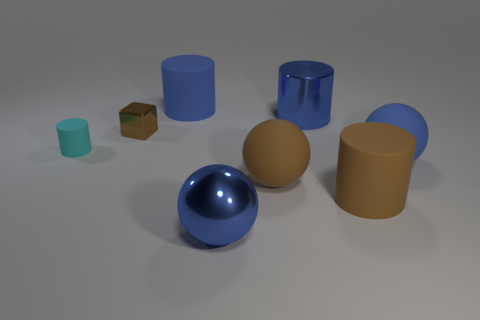Is there anything else that is the same shape as the small brown object?
Offer a very short reply. No. Is the shape of the tiny cyan rubber thing the same as the big blue shiny thing that is behind the tiny rubber cylinder?
Offer a very short reply. Yes. Is there a large matte cylinder that has the same color as the metallic cylinder?
Keep it short and to the point. Yes. How many cylinders are big blue objects or large blue metal things?
Your response must be concise. 2. Are there any blue rubber things of the same shape as the cyan matte thing?
Your answer should be compact. Yes. How many other things are there of the same color as the cube?
Your response must be concise. 2. Are there fewer brown objects left of the small cyan matte cylinder than brown shiny objects?
Make the answer very short. Yes. What number of matte things are there?
Provide a short and direct response. 5. What number of other cyan objects are the same material as the tiny cyan object?
Provide a succinct answer. 0. What number of objects are either big spheres that are in front of the big brown cylinder or large brown cylinders?
Provide a short and direct response. 2. 